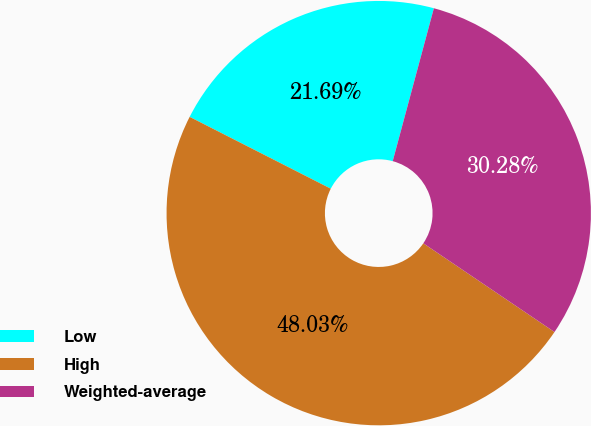Convert chart to OTSL. <chart><loc_0><loc_0><loc_500><loc_500><pie_chart><fcel>Low<fcel>High<fcel>Weighted-average<nl><fcel>21.69%<fcel>48.03%<fcel>30.28%<nl></chart> 